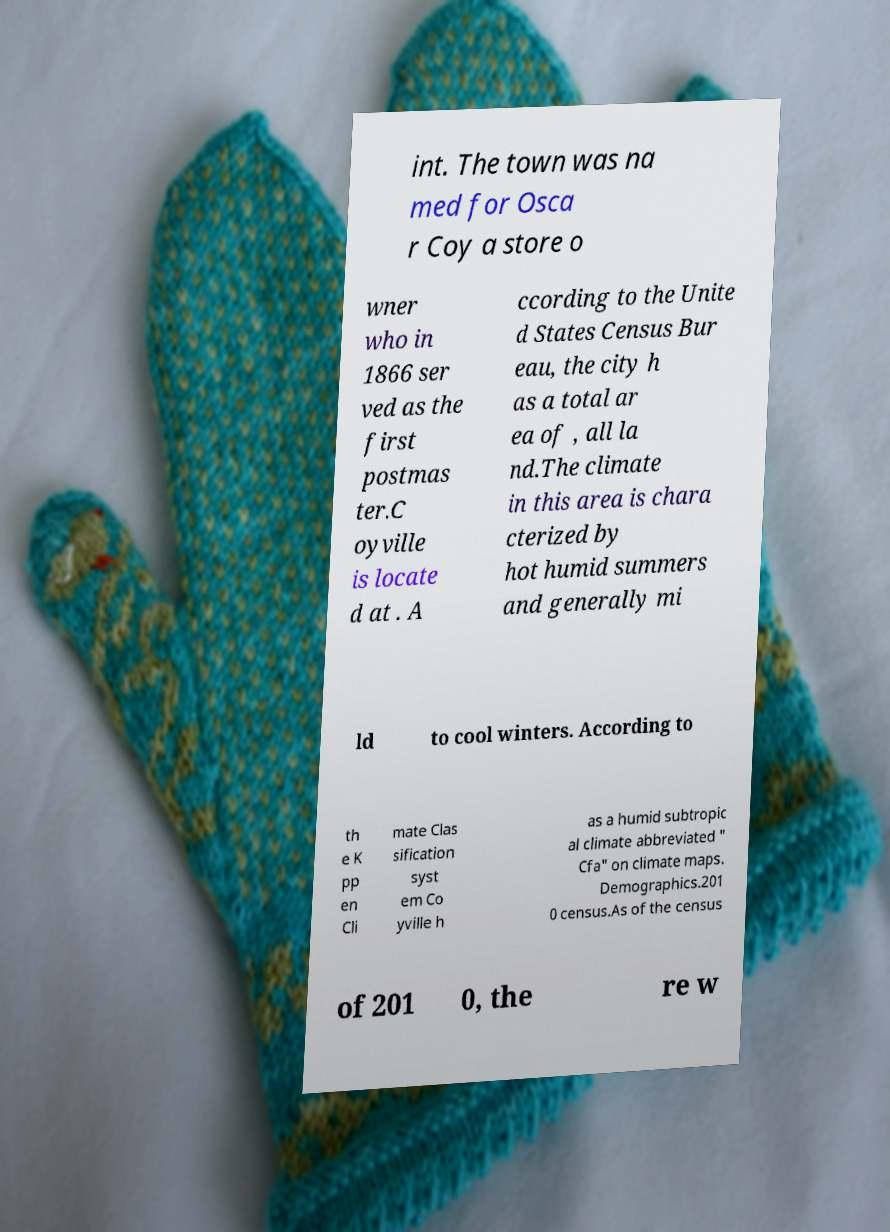I need the written content from this picture converted into text. Can you do that? int. The town was na med for Osca r Coy a store o wner who in 1866 ser ved as the first postmas ter.C oyville is locate d at . A ccording to the Unite d States Census Bur eau, the city h as a total ar ea of , all la nd.The climate in this area is chara cterized by hot humid summers and generally mi ld to cool winters. According to th e K pp en Cli mate Clas sification syst em Co yville h as a humid subtropic al climate abbreviated " Cfa" on climate maps. Demographics.201 0 census.As of the census of 201 0, the re w 